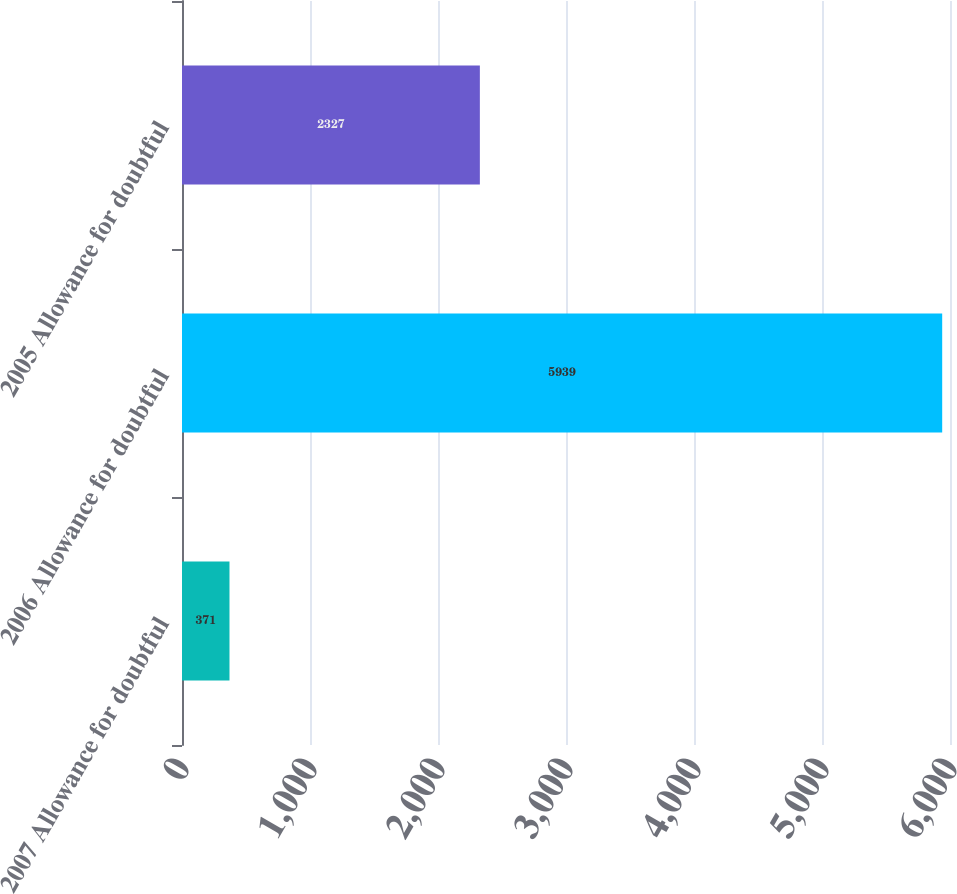Convert chart to OTSL. <chart><loc_0><loc_0><loc_500><loc_500><bar_chart><fcel>2007 Allowance for doubtful<fcel>2006 Allowance for doubtful<fcel>2005 Allowance for doubtful<nl><fcel>371<fcel>5939<fcel>2327<nl></chart> 